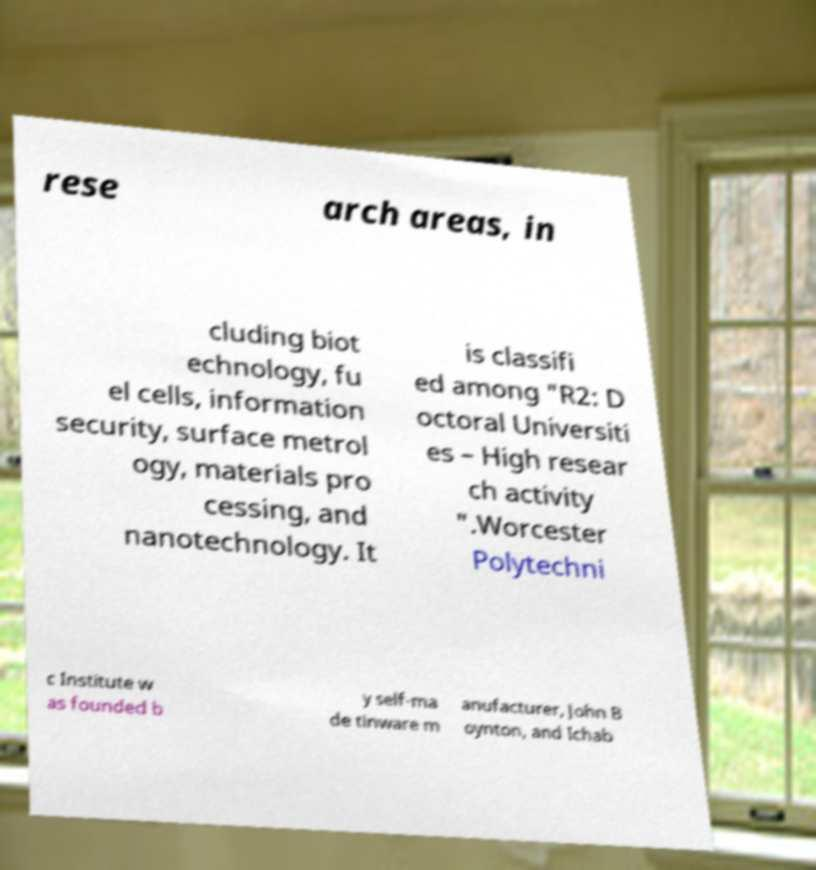Could you assist in decoding the text presented in this image and type it out clearly? rese arch areas, in cluding biot echnology, fu el cells, information security, surface metrol ogy, materials pro cessing, and nanotechnology. It is classifi ed among "R2: D octoral Universiti es – High resear ch activity ".Worcester Polytechni c Institute w as founded b y self-ma de tinware m anufacturer, John B oynton, and Ichab 